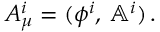Convert formula to latex. <formula><loc_0><loc_0><loc_500><loc_500>A _ { \mu } ^ { i } = ( \phi ^ { i } , \, \mathbb { A } ^ { i } ) \, .</formula> 